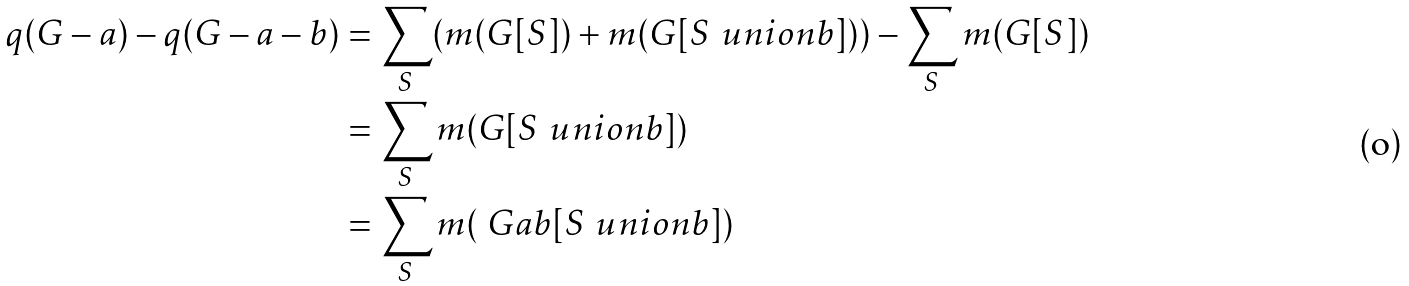Convert formula to latex. <formula><loc_0><loc_0><loc_500><loc_500>q ( G - a ) - q ( G - a - b ) & = \sum _ { S } ( m ( G [ S ] ) + m ( G [ S \ u n i o n b ] ) ) - \sum _ { S } m ( G [ S ] ) \\ & = \sum _ { S } m ( G [ S \ u n i o n b ] ) \\ & = \sum _ { S } m ( \ G a b [ S \ u n i o n b ] )</formula> 